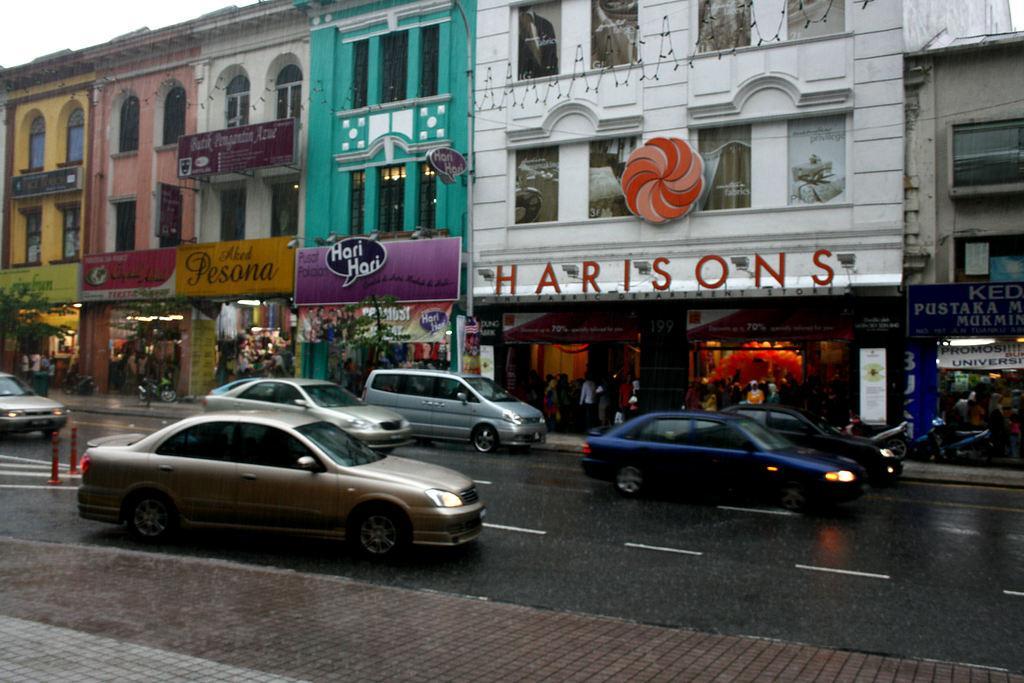In one or two sentences, can you explain what this image depicts? In the foreground of this image, there is pavement and vehicles moving on the road. In the background, there are buildings, boards and the sky. 